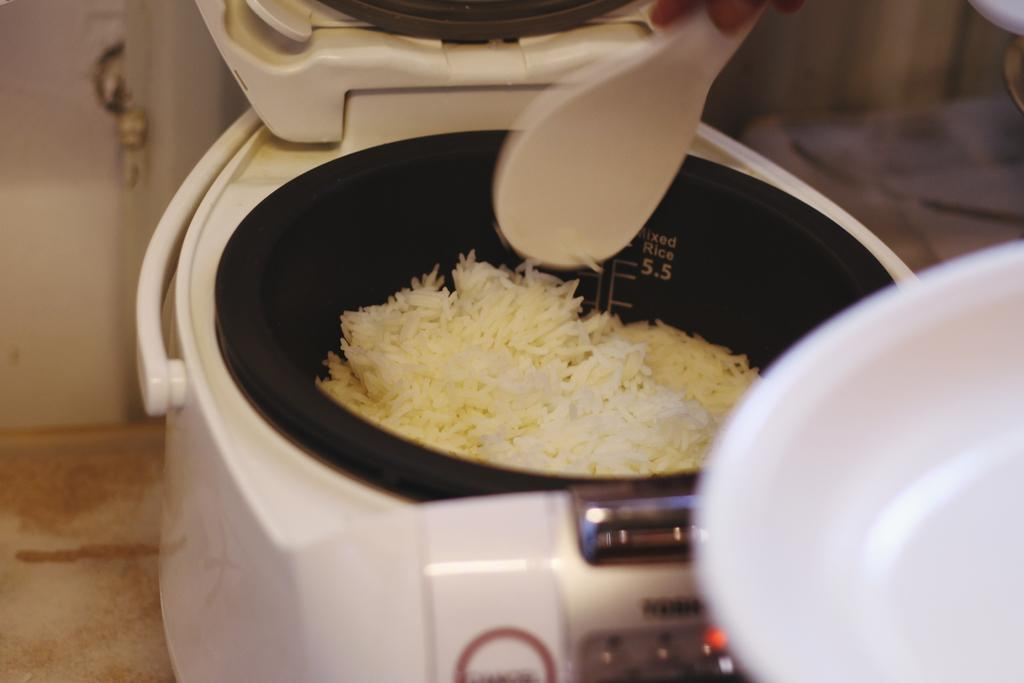<image>
Create a compact narrative representing the image presented. A container of rice has the words Mixed Rice printed on its inside. 